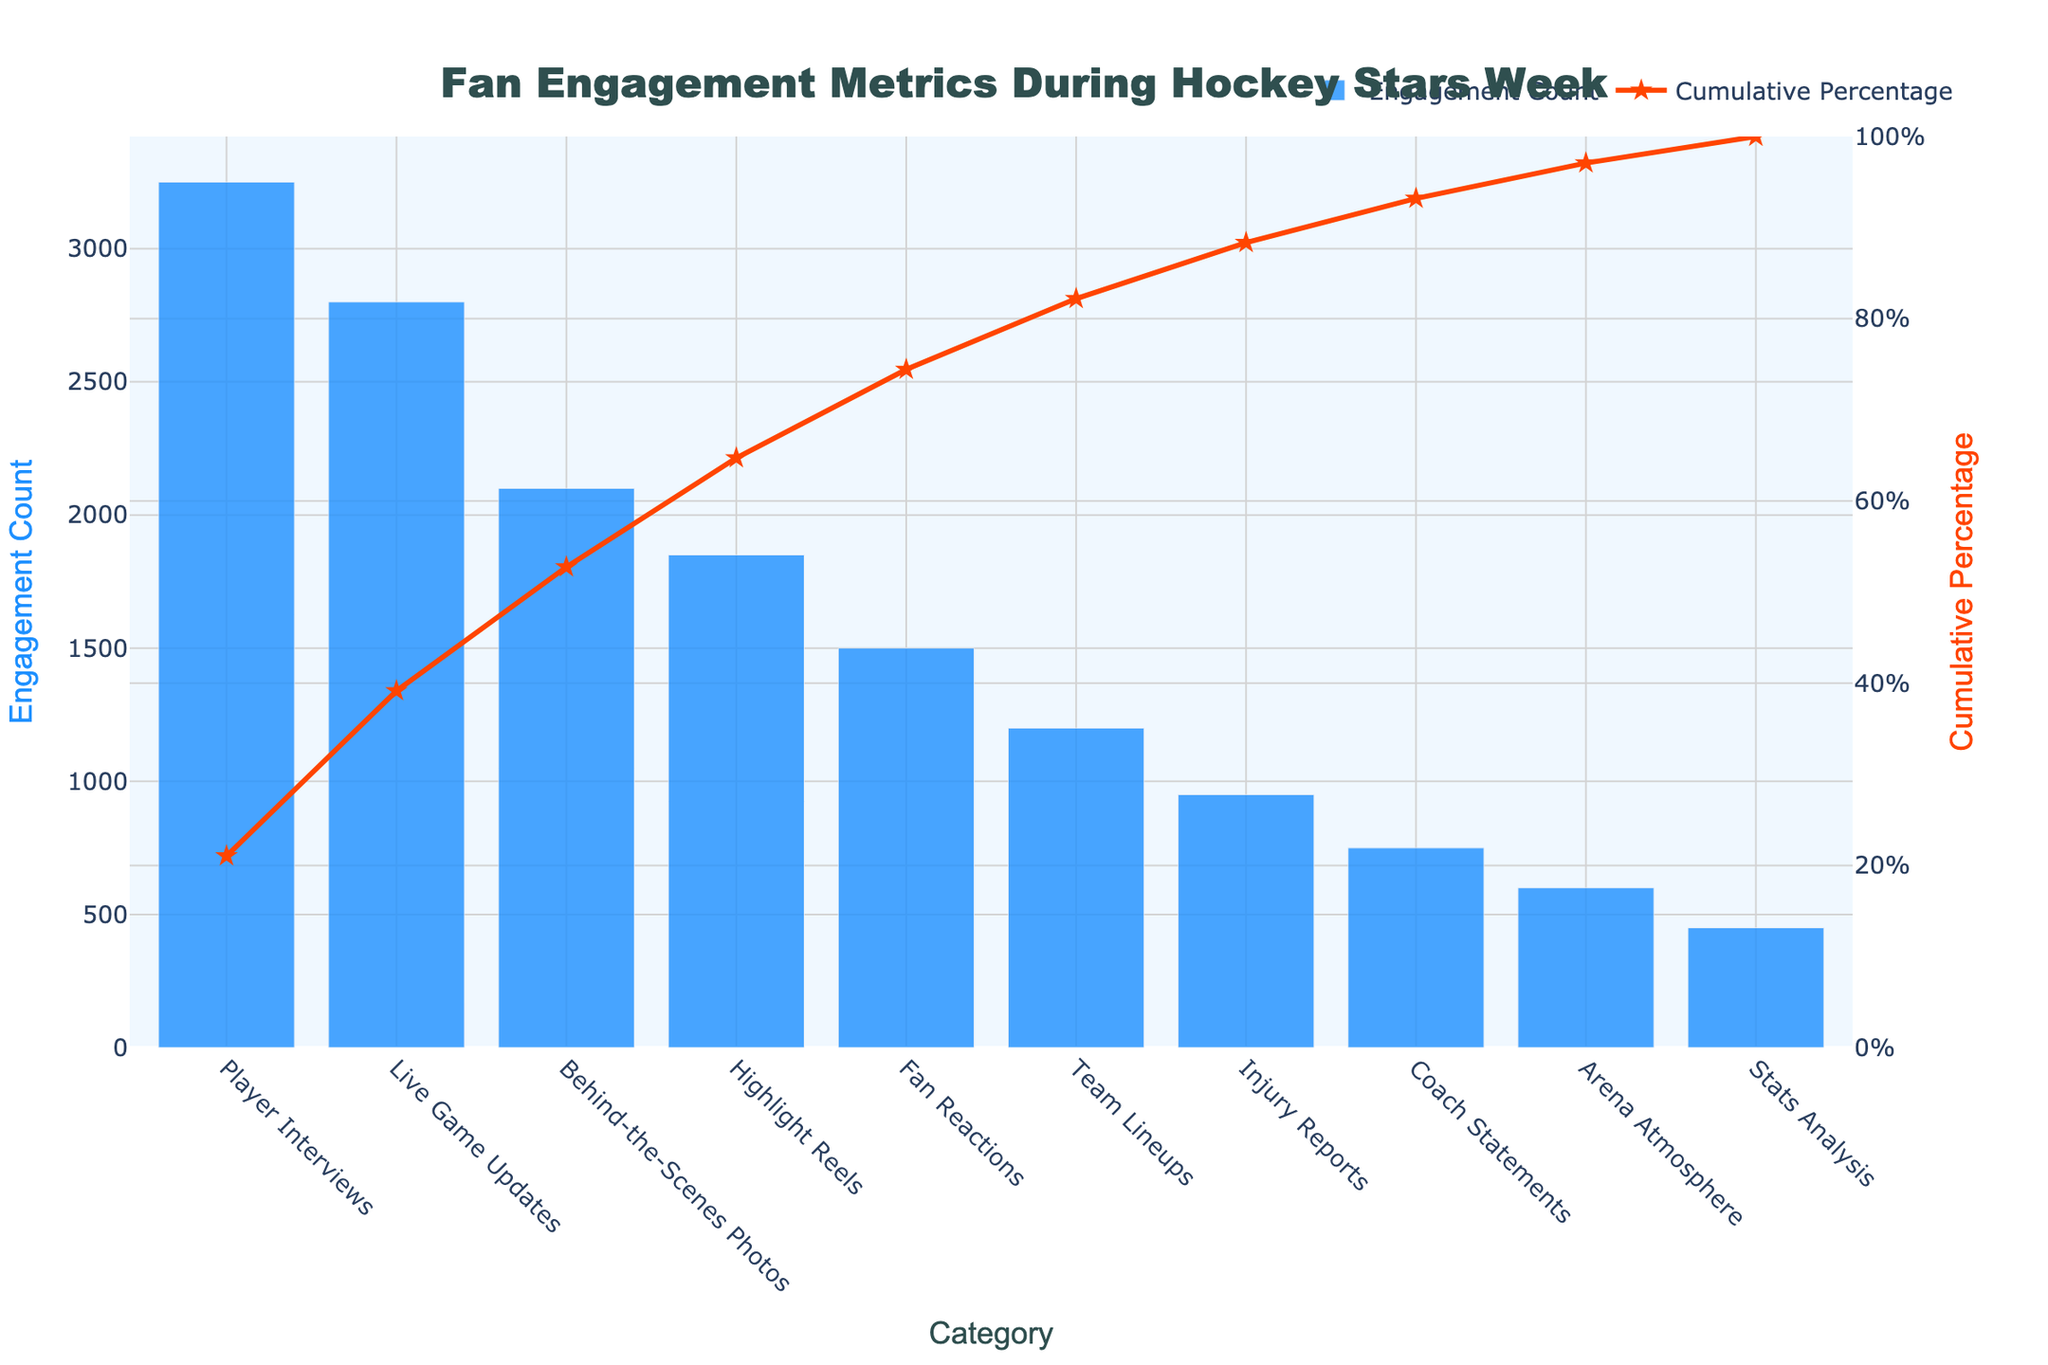What's the title of the figure? The title of the figure is prominently displayed at the top center of the plot. It provides a summary of what the chart is about.
Answer: Fan Engagement Metrics During Hockey Stars Week How many categories are displayed in the Pareto chart? You can count the distinct bars along the x-axis of the chart to determine the number of categories.
Answer: 10 Which category has the highest engagement count? The category with the highest engagement count will have the tallest bar in the chart.
Answer: Player Interviews What is the engagement count for Live Game Updates? Locate the bar corresponding to 'Live Game Updates' and read the value associated with its height.
Answer: 2800 What cumulative percentage does Player Interviews contribute to? Follow the line graph associated with 'Player Interviews' on the secondary y-axis (right side) to find the cumulative percentage.
Answer: Approximately 20% What is the total engagement count for Player Interviews, Live Game Updates, and Behind-the-Scenes Photos combined? Sum the engagement counts for these categories: Player Interviews (3250) + Live Game Updates (2800) + Behind-the-Scenes Photos (2100).
Answer: 8150 Which category has a higher engagement count: Highlight Reels or Fan Reactions? Compare the heights of the bars for Highlight Reels and Fan Reactions.
Answer: Highlight Reels What percentage of total engagement is covered by the top 3 categories? Sum the cumulative percentages for Player Interviews, Live Game Updates, and Behind-the-Scenes Photos. With Player Interviews at ~20%, Live Game Updates at ~37%, and Behind-the-Scenes Photos at ~53%, the combined total is their sum.
Answer: Approximately 53% What is the difference in engagement counts between Team Lineups and Injury Reports? Subtract the engagement count of Injury Reports from Team Lineups: 1200 - 950.
Answer: 250 How does the engagement count for Coach Statements compare with Arena Atmosphere? Compare the heights of the bars for Coach Statements and Arena Atmosphere to see which one is higher.
Answer: Coach Statements 